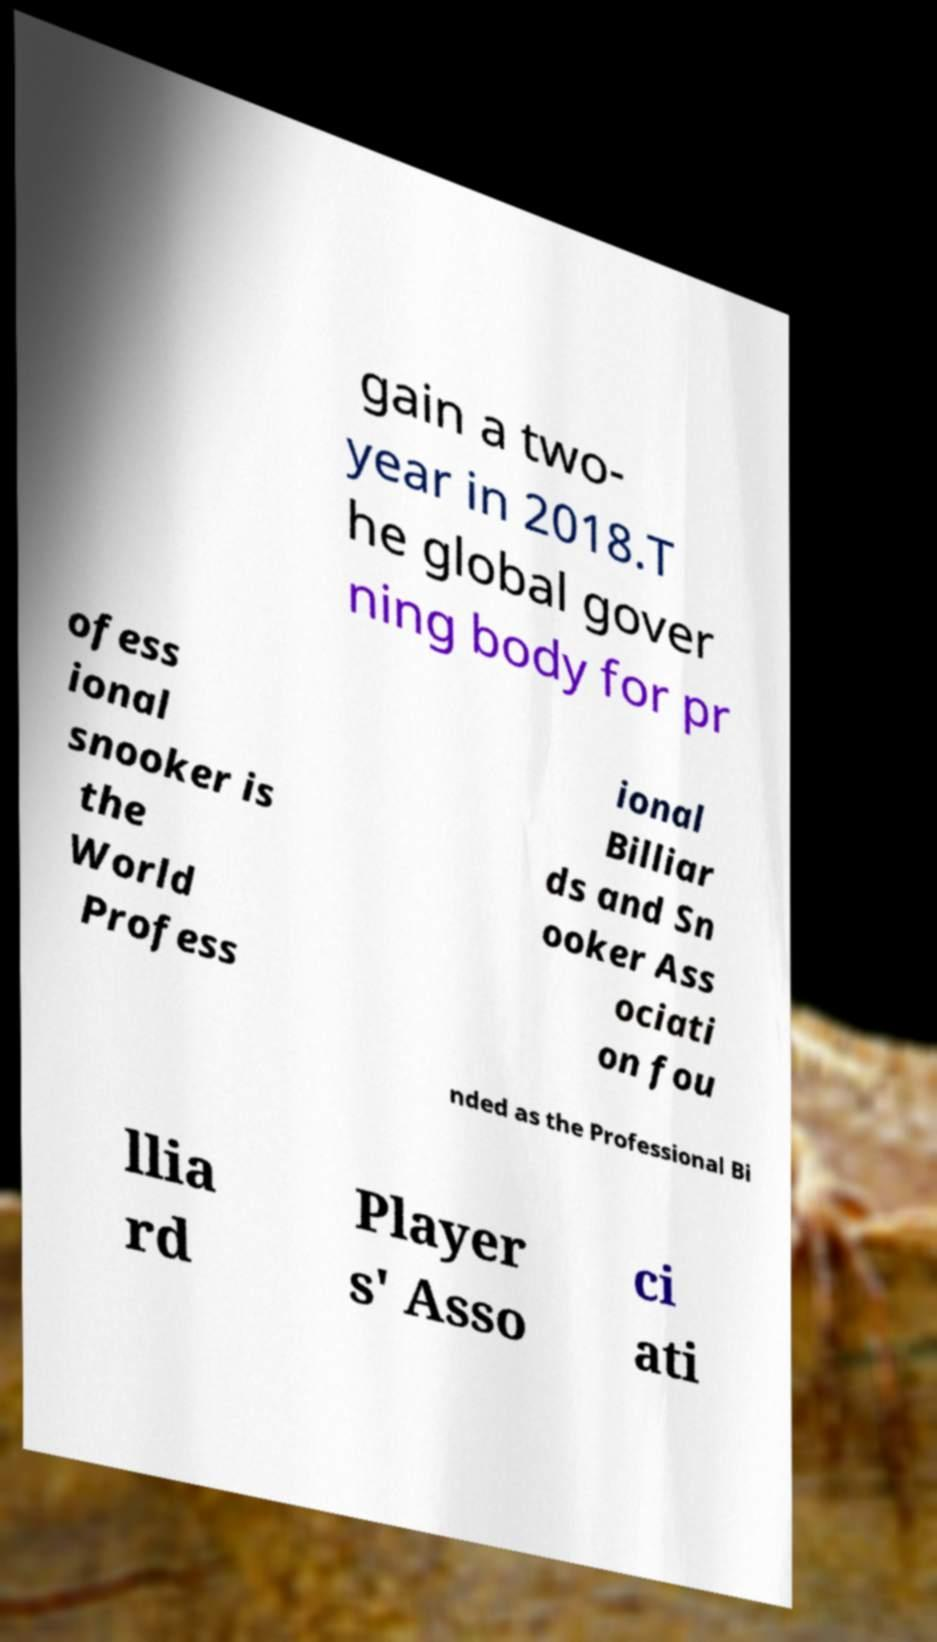Can you accurately transcribe the text from the provided image for me? gain a two- year in 2018.T he global gover ning body for pr ofess ional snooker is the World Profess ional Billiar ds and Sn ooker Ass ociati on fou nded as the Professional Bi llia rd Player s' Asso ci ati 